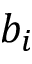Convert formula to latex. <formula><loc_0><loc_0><loc_500><loc_500>b _ { i }</formula> 